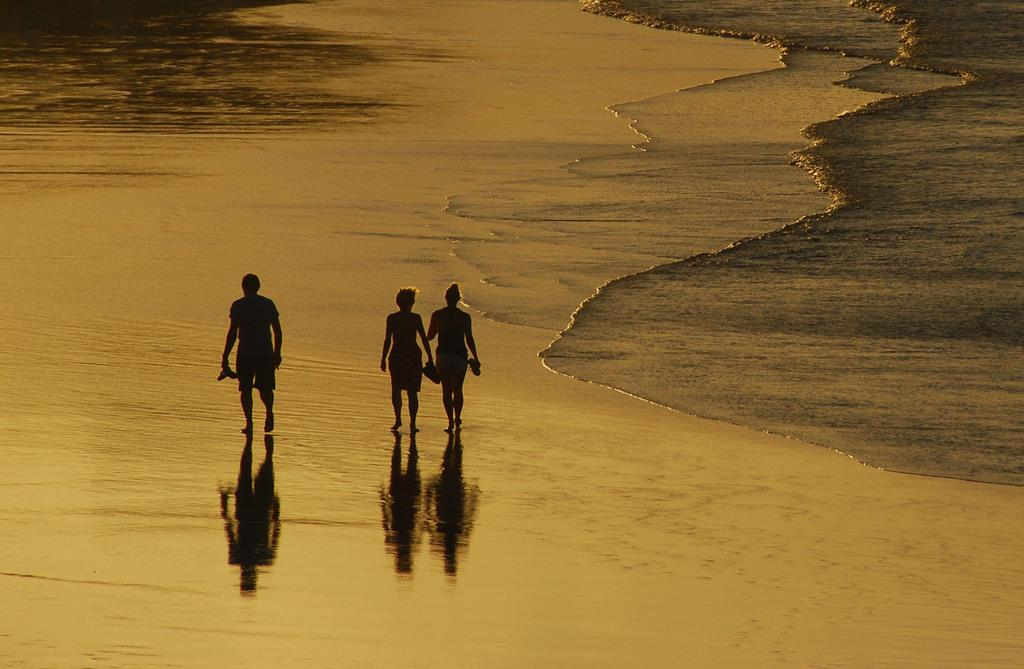What type of location is shown in the image? The image depicts a beach. What natural phenomenon can be observed in the image? Water waves are coming onto the land. What are the people in the image doing? People are walking on the beach. What type of bed can be seen in the alley near the beach? There is no bed or alley present in the image; it only shows a beach with people walking on it. 